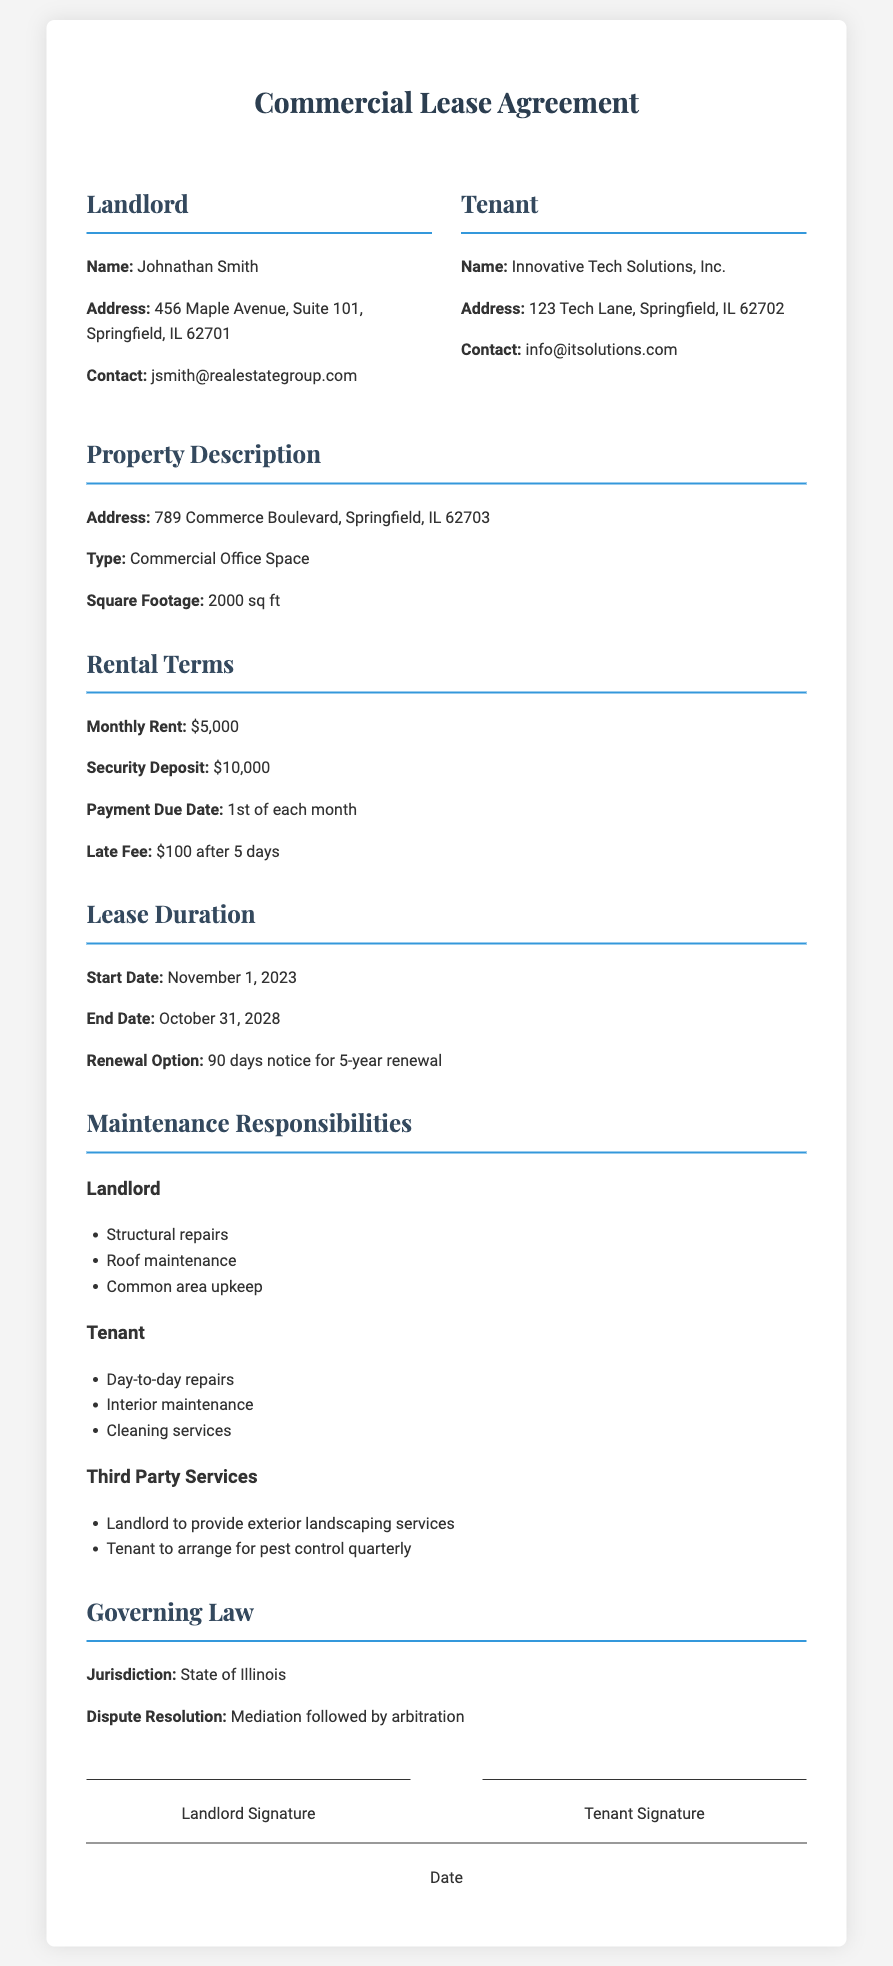What is the name of the landlord? The landlord's name is listed in the party information section.
Answer: Johnathan Smith What is the address of the property? The property address can be found in the property description section.
Answer: 789 Commerce Boulevard, Springfield, IL 62703 What is the monthly rent amount? The rental terms section specifies the monthly rent amount.
Answer: $5,000 When does the lease start? The lease start date is specified under the lease duration section.
Answer: November 1, 2023 What is the duration of the lease? The duration of the lease is detailed in the lease duration section with start and end dates.
Answer: 5 years Who is responsible for structural repairs? Maintenance responsibilities section outlines which party is responsible for specific repairs.
Answer: Landlord What option does the tenant have for lease renewal? The lease renewal option is detailed in the lease duration section.
Answer: 90 days notice for 5-year renewal How much is the security deposit? The amount for the security deposit is specified in the rental terms section.
Answer: $10,000 What is the late fee amount? The late fee is outlined in the rental terms section and specifies the conditions.
Answer: $100 after 5 days What governing law applies to this agreement? The governing law section indicates the jurisdiction for the agreement.
Answer: State of Illinois 